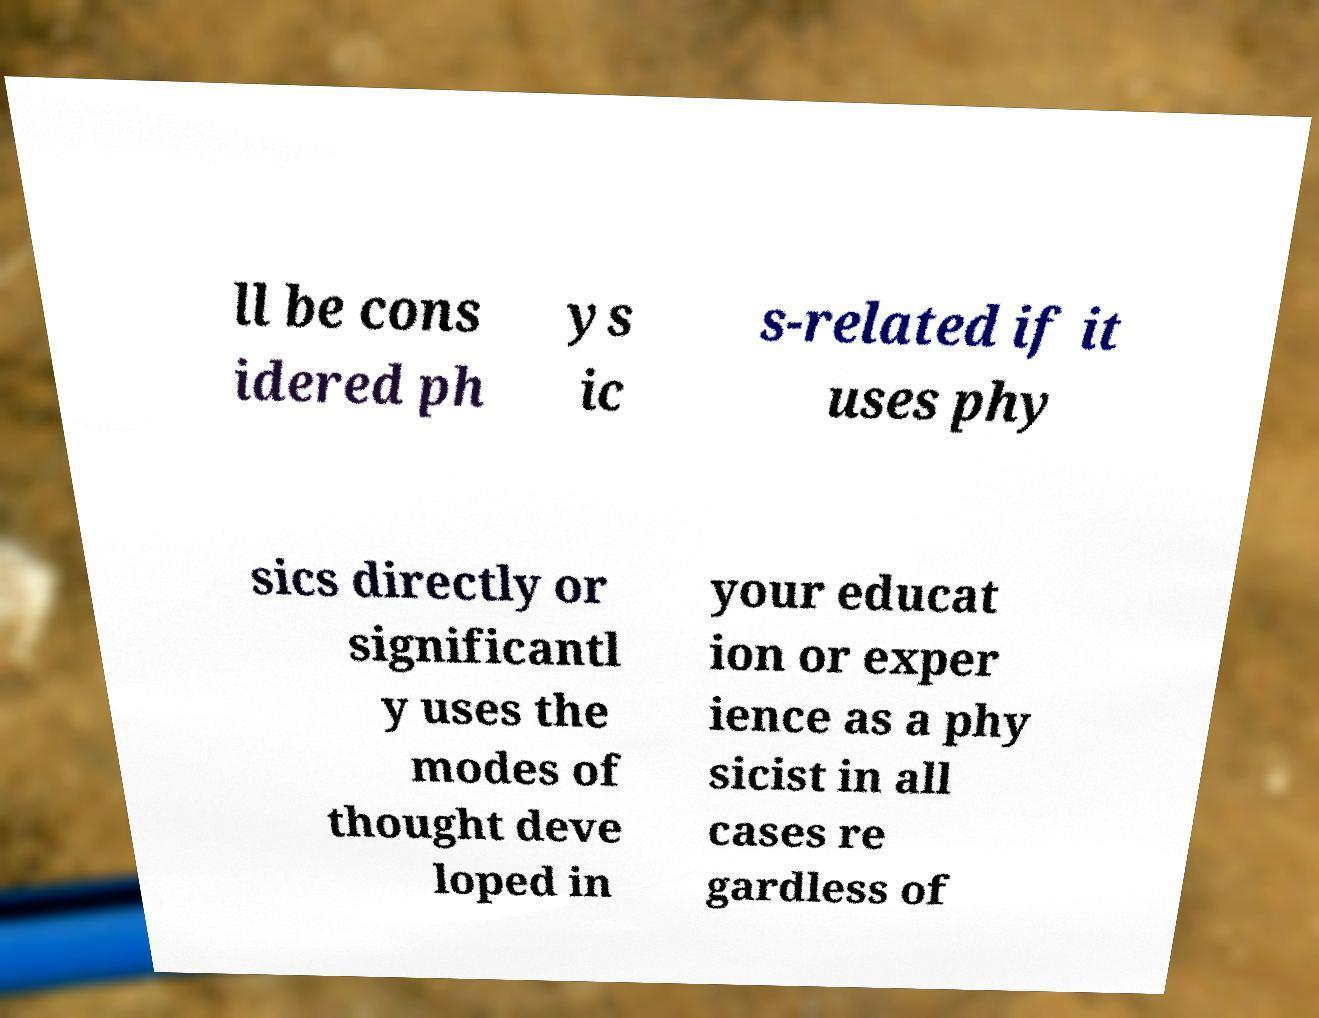Please identify and transcribe the text found in this image. ll be cons idered ph ys ic s-related if it uses phy sics directly or significantl y uses the modes of thought deve loped in your educat ion or exper ience as a phy sicist in all cases re gardless of 